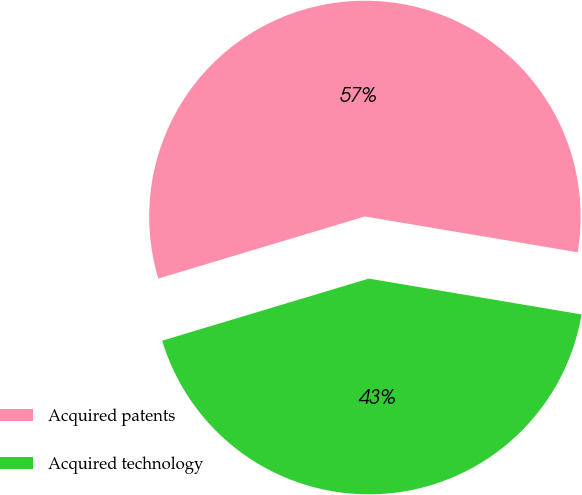<chart> <loc_0><loc_0><loc_500><loc_500><pie_chart><fcel>Acquired patents<fcel>Acquired technology<nl><fcel>57.3%<fcel>42.7%<nl></chart> 